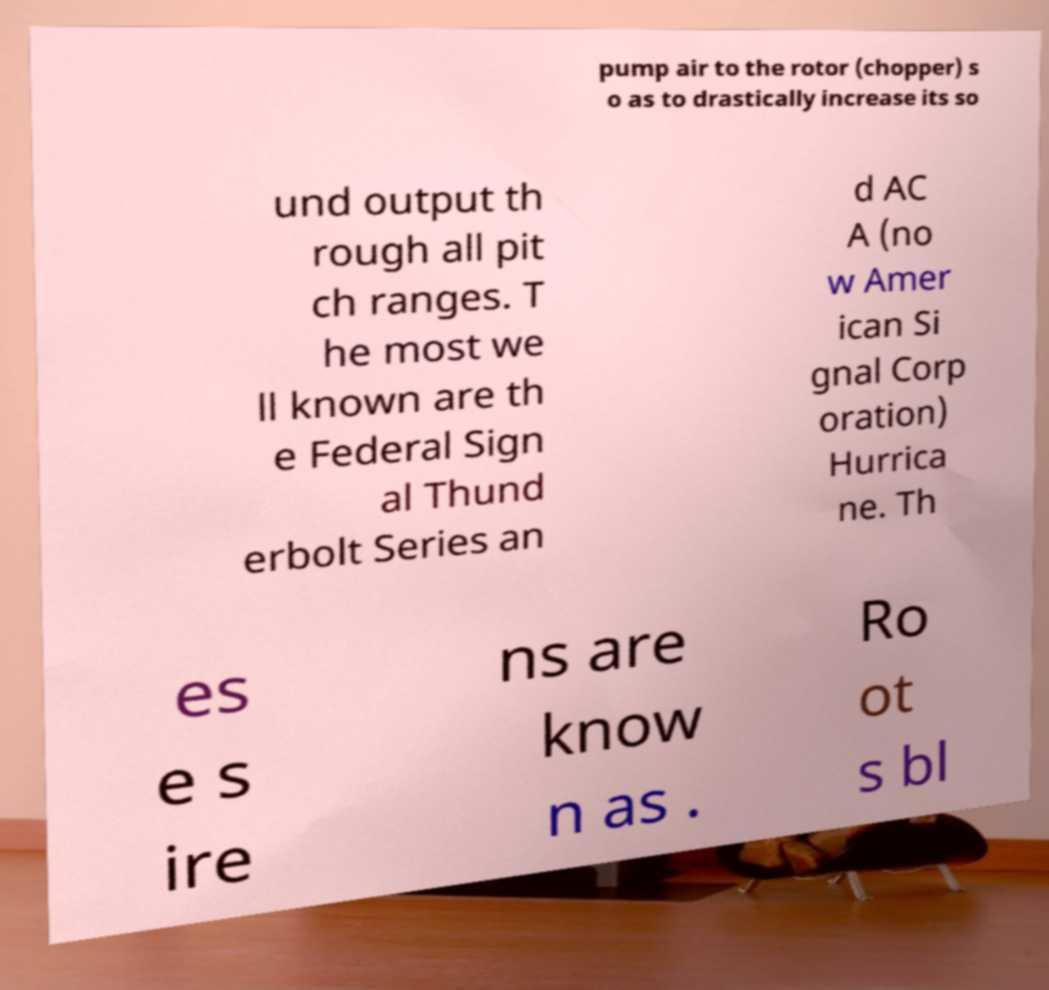Please identify and transcribe the text found in this image. pump air to the rotor (chopper) s o as to drastically increase its so und output th rough all pit ch ranges. T he most we ll known are th e Federal Sign al Thund erbolt Series an d AC A (no w Amer ican Si gnal Corp oration) Hurrica ne. Th es e s ire ns are know n as . Ro ot s bl 